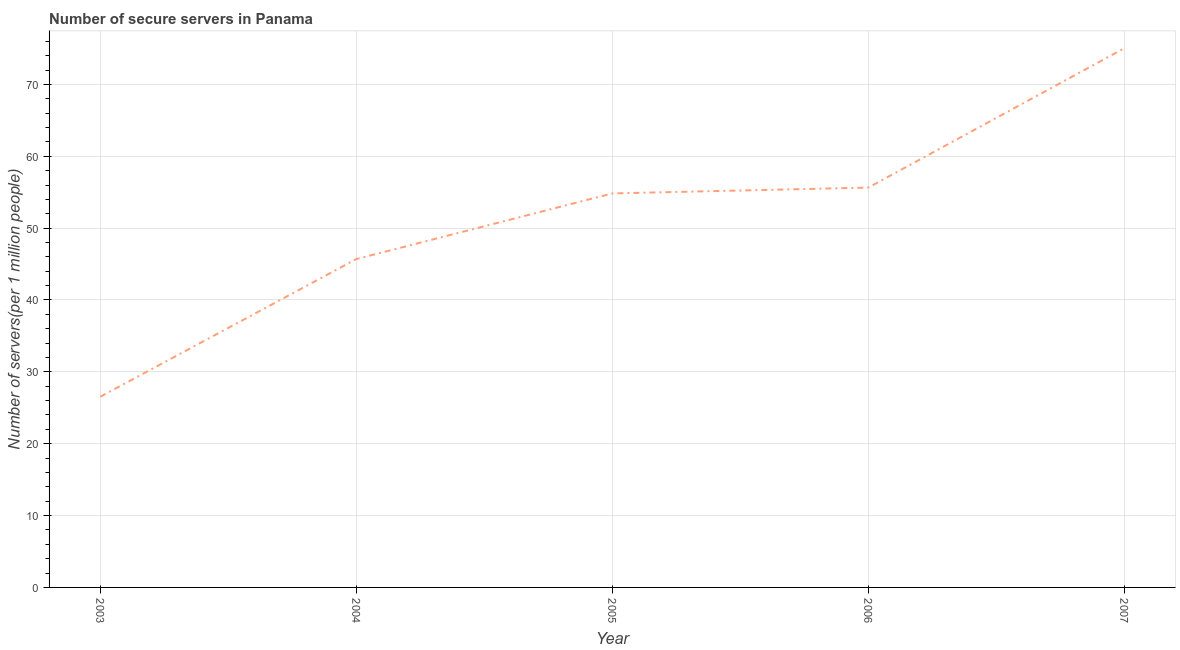What is the number of secure internet servers in 2005?
Offer a very short reply. 54.83. Across all years, what is the maximum number of secure internet servers?
Provide a short and direct response. 75.03. Across all years, what is the minimum number of secure internet servers?
Ensure brevity in your answer.  26.54. In which year was the number of secure internet servers minimum?
Your answer should be compact. 2003. What is the sum of the number of secure internet servers?
Your answer should be very brief. 257.75. What is the difference between the number of secure internet servers in 2004 and 2007?
Your answer should be compact. -29.34. What is the average number of secure internet servers per year?
Your answer should be very brief. 51.55. What is the median number of secure internet servers?
Make the answer very short. 54.83. In how many years, is the number of secure internet servers greater than 24 ?
Keep it short and to the point. 5. Do a majority of the years between 2004 and 2005 (inclusive) have number of secure internet servers greater than 70 ?
Offer a very short reply. No. What is the ratio of the number of secure internet servers in 2003 to that in 2007?
Your response must be concise. 0.35. Is the difference between the number of secure internet servers in 2003 and 2005 greater than the difference between any two years?
Provide a short and direct response. No. What is the difference between the highest and the second highest number of secure internet servers?
Your response must be concise. 19.39. What is the difference between the highest and the lowest number of secure internet servers?
Ensure brevity in your answer.  48.49. How many lines are there?
Make the answer very short. 1. Are the values on the major ticks of Y-axis written in scientific E-notation?
Your response must be concise. No. Does the graph contain grids?
Your answer should be very brief. Yes. What is the title of the graph?
Keep it short and to the point. Number of secure servers in Panama. What is the label or title of the Y-axis?
Your answer should be compact. Number of servers(per 1 million people). What is the Number of servers(per 1 million people) of 2003?
Your response must be concise. 26.54. What is the Number of servers(per 1 million people) in 2004?
Provide a short and direct response. 45.7. What is the Number of servers(per 1 million people) in 2005?
Your answer should be compact. 54.83. What is the Number of servers(per 1 million people) in 2006?
Keep it short and to the point. 55.64. What is the Number of servers(per 1 million people) in 2007?
Offer a terse response. 75.03. What is the difference between the Number of servers(per 1 million people) in 2003 and 2004?
Keep it short and to the point. -19.16. What is the difference between the Number of servers(per 1 million people) in 2003 and 2005?
Make the answer very short. -28.29. What is the difference between the Number of servers(per 1 million people) in 2003 and 2006?
Provide a short and direct response. -29.1. What is the difference between the Number of servers(per 1 million people) in 2003 and 2007?
Give a very brief answer. -48.49. What is the difference between the Number of servers(per 1 million people) in 2004 and 2005?
Offer a terse response. -9.13. What is the difference between the Number of servers(per 1 million people) in 2004 and 2006?
Your response must be concise. -9.95. What is the difference between the Number of servers(per 1 million people) in 2004 and 2007?
Offer a very short reply. -29.34. What is the difference between the Number of servers(per 1 million people) in 2005 and 2006?
Provide a short and direct response. -0.81. What is the difference between the Number of servers(per 1 million people) in 2005 and 2007?
Keep it short and to the point. -20.2. What is the difference between the Number of servers(per 1 million people) in 2006 and 2007?
Give a very brief answer. -19.39. What is the ratio of the Number of servers(per 1 million people) in 2003 to that in 2004?
Your answer should be compact. 0.58. What is the ratio of the Number of servers(per 1 million people) in 2003 to that in 2005?
Your answer should be compact. 0.48. What is the ratio of the Number of servers(per 1 million people) in 2003 to that in 2006?
Your answer should be compact. 0.48. What is the ratio of the Number of servers(per 1 million people) in 2003 to that in 2007?
Give a very brief answer. 0.35. What is the ratio of the Number of servers(per 1 million people) in 2004 to that in 2005?
Keep it short and to the point. 0.83. What is the ratio of the Number of servers(per 1 million people) in 2004 to that in 2006?
Provide a succinct answer. 0.82. What is the ratio of the Number of servers(per 1 million people) in 2004 to that in 2007?
Keep it short and to the point. 0.61. What is the ratio of the Number of servers(per 1 million people) in 2005 to that in 2007?
Offer a terse response. 0.73. What is the ratio of the Number of servers(per 1 million people) in 2006 to that in 2007?
Provide a succinct answer. 0.74. 